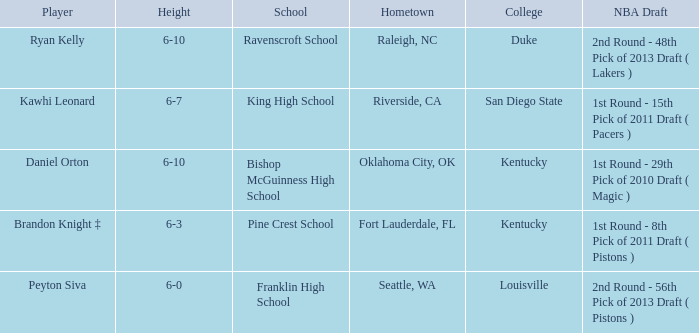Which height is associated with Franklin High School? 6-0. 